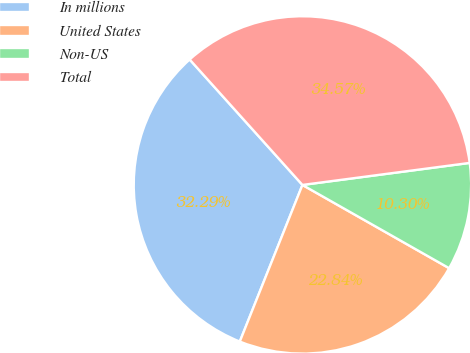Convert chart. <chart><loc_0><loc_0><loc_500><loc_500><pie_chart><fcel>In millions<fcel>United States<fcel>Non-US<fcel>Total<nl><fcel>32.29%<fcel>22.84%<fcel>10.3%<fcel>34.57%<nl></chart> 